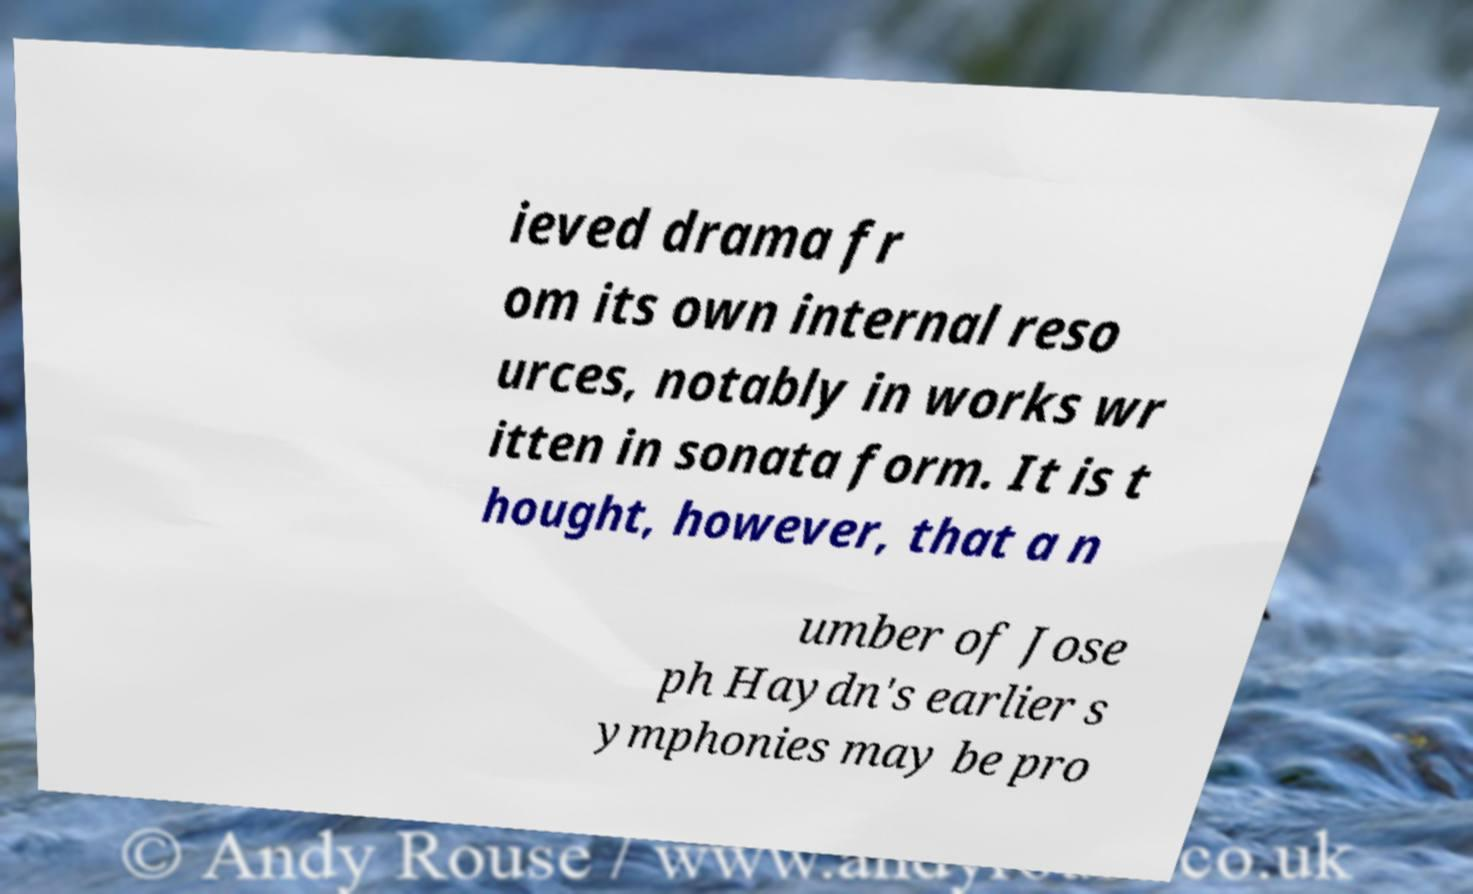For documentation purposes, I need the text within this image transcribed. Could you provide that? ieved drama fr om its own internal reso urces, notably in works wr itten in sonata form. It is t hought, however, that a n umber of Jose ph Haydn's earlier s ymphonies may be pro 